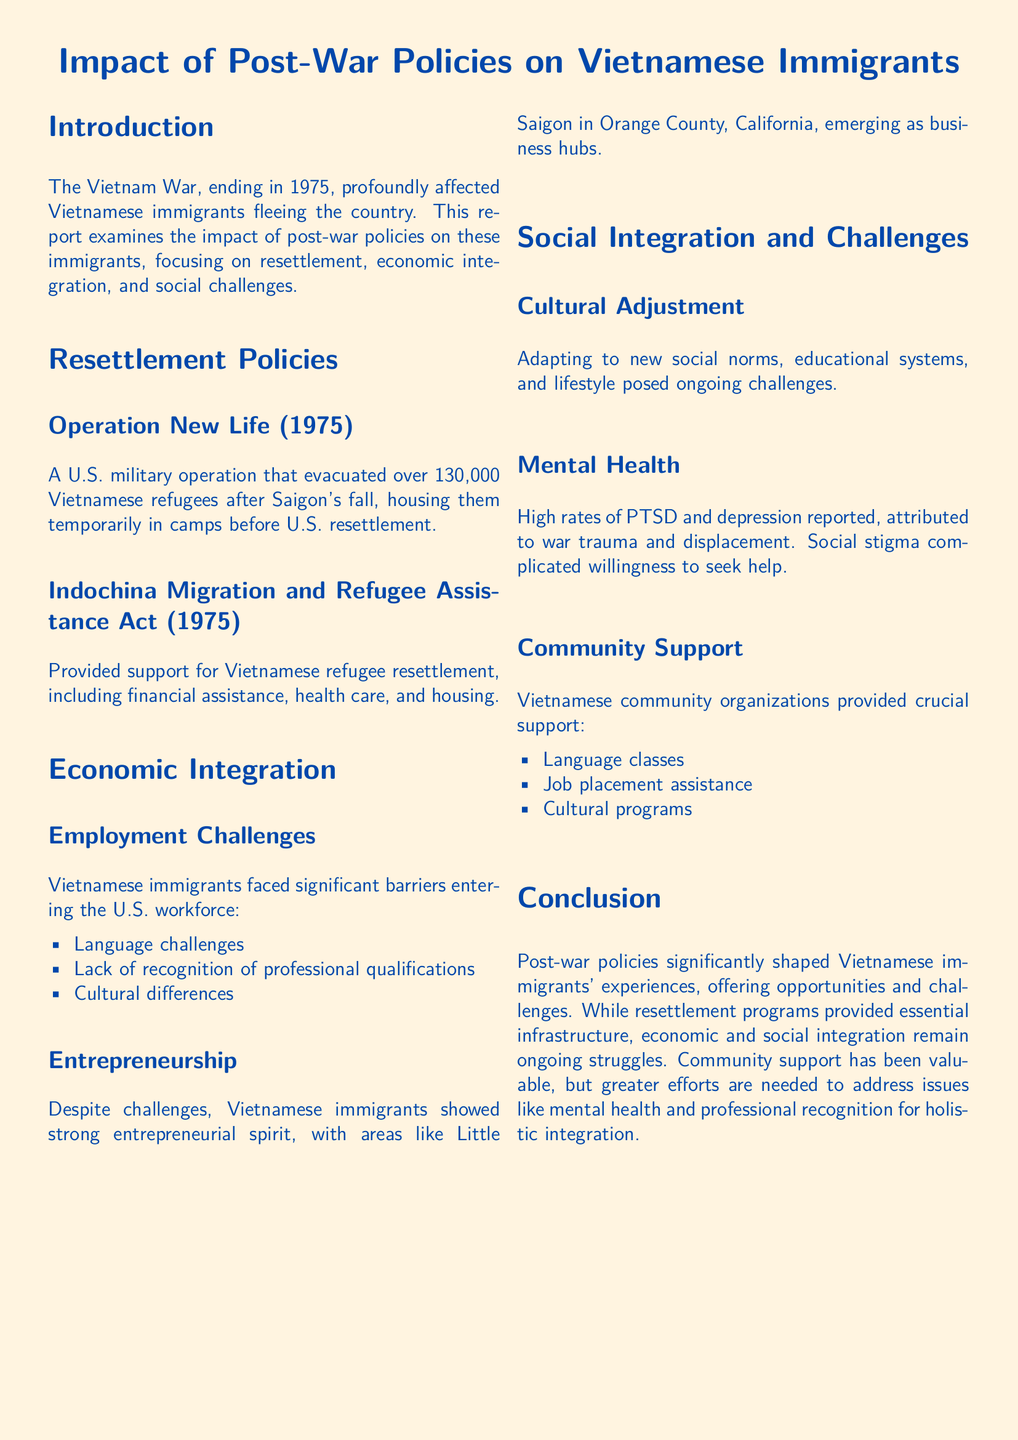What operation evacuated Vietnamese refugees in 1975? The document states that Operation New Life evacuated over 130,000 Vietnamese refugees after Saigon's fall.
Answer: Operation New Life How many Vietnamese refugees did Operation New Life evacuate? The document mentions that Operation New Life evacuated over 130,000 Vietnamese refugees.
Answer: Over 130,000 What act provided support for Vietnamese refugee resettlement? The document indicates that the Indochina Migration and Refugee Assistance Act provided support for resettlement.
Answer: Indochina Migration and Refugee Assistance Act What was a significant barrier for Vietnamese immigrants in the workforce? The document lists language challenges as a significant barrier for employment.
Answer: Language challenges Which area became a business hub for Vietnamese immigrants? The document states that Little Saigon in Orange County, California, emerged as a business hub.
Answer: Little Saigon What mental health issue was reported among Vietnamese immigrants? The document discusses high rates of PTSD reported among Vietnamese immigrants.
Answer: PTSD What type of support do Vietnamese community organizations provide? The document mentions that community organizations provide language classes.
Answer: Language classes What remains a struggle for Vietnamese immigrants according to the conclusion? The document states that economic and social integration remains an ongoing struggle.
Answer: Economic and social integration What year did the Vietnam War end? The document specifies that the Vietnam War ended in 1975.
Answer: 1975 